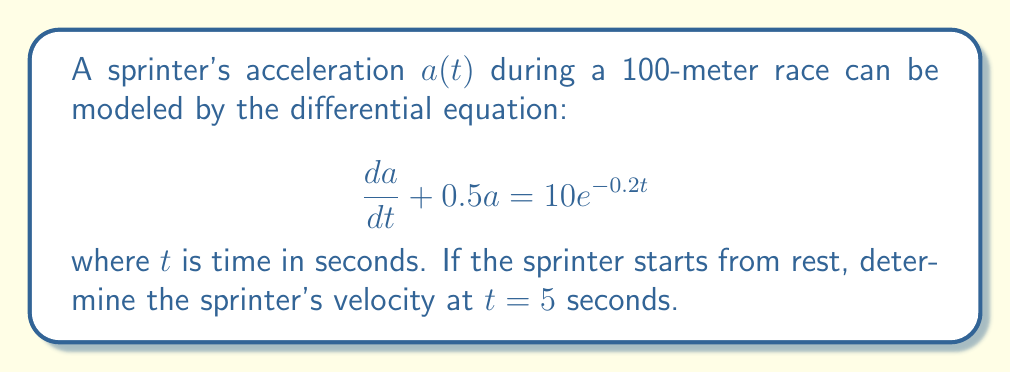Solve this math problem. To solve this problem, we need to follow these steps:

1) First, we need to solve the differential equation for $a(t)$. This is a first-order linear differential equation.

2) The general solution for this type of equation is:

   $$a(t) = e^{-0.5t}(\int 10e^{-0.2t} \cdot e^{0.5t} dt + C)$$

3) Solving the integral:

   $$a(t) = e^{-0.5t}(\frac{10}{0.3}e^{0.3t} + C)$$

4) To find $C$, we use the initial condition. The sprinter starts from rest, so $a(0) = 0$:

   $$0 = \frac{10}{0.3} + C$$
   $$C = -\frac{10}{0.3}$$

5) Substituting this back into our solution:

   $$a(t) = \frac{10}{0.3}(e^{-0.2t} - e^{-0.5t})$$

6) To find velocity, we need to integrate $a(t)$:

   $$v(t) = \int a(t) dt = \frac{10}{0.3}(-5e^{-0.2t} + 2e^{-0.5t}) + K$$

7) Since the sprinter starts from rest, $v(0) = 0$. We can use this to find $K$:

   $$0 = \frac{10}{0.3}(-5 + 2) + K$$
   $$K = 10$$

8) Our final velocity function is:

   $$v(t) = \frac{10}{0.3}(-5e^{-0.2t} + 2e^{-0.5t}) + 10$$

9) Now we can calculate $v(5)$:

   $$v(5) = \frac{10}{0.3}(-5e^{-1} + 2e^{-2.5}) + 10$$
Answer: $v(5) \approx 11.57$ m/s 